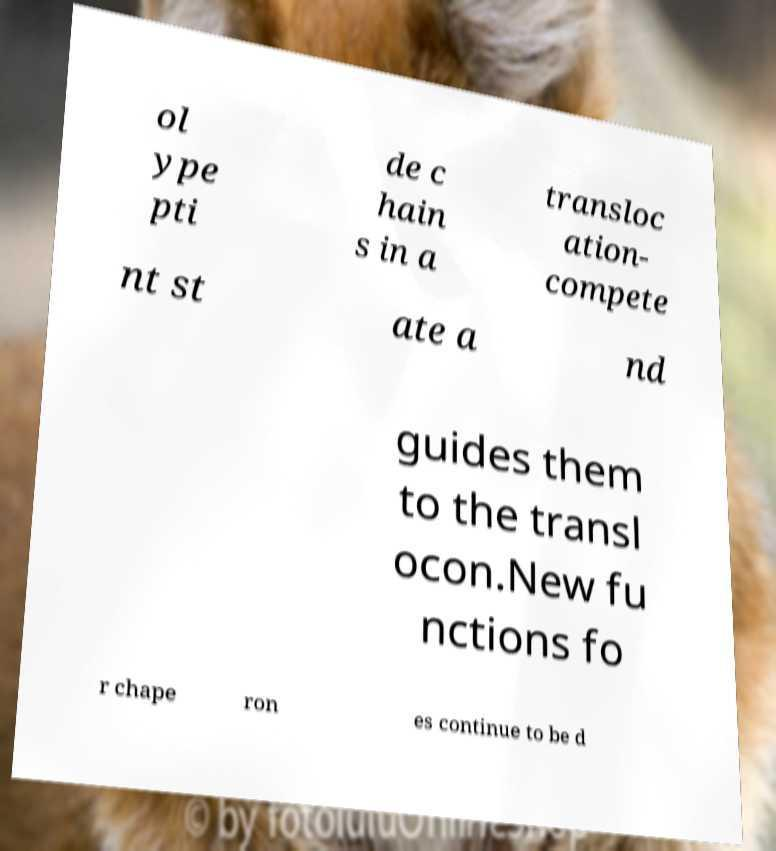Please identify and transcribe the text found in this image. ol ype pti de c hain s in a transloc ation- compete nt st ate a nd guides them to the transl ocon.New fu nctions fo r chape ron es continue to be d 